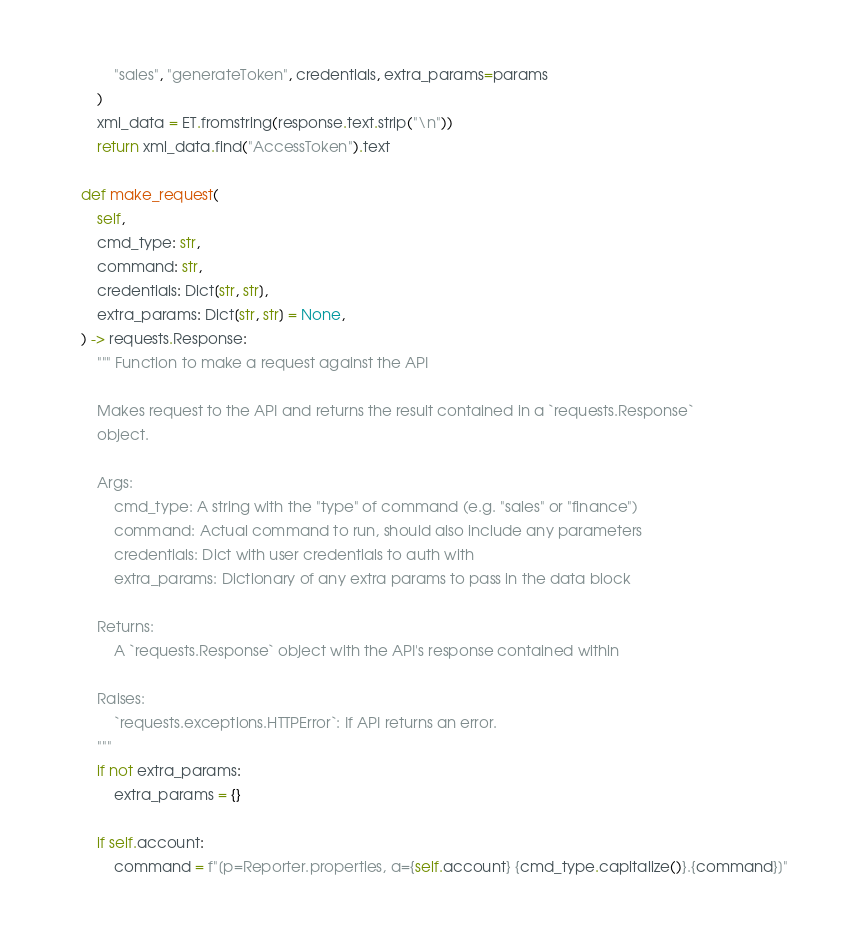Convert code to text. <code><loc_0><loc_0><loc_500><loc_500><_Python_>            "sales", "generateToken", credentials, extra_params=params
        )
        xml_data = ET.fromstring(response.text.strip("\n"))
        return xml_data.find("AccessToken").text

    def make_request(
        self,
        cmd_type: str,
        command: str,
        credentials: Dict[str, str],
        extra_params: Dict[str, str] = None,
    ) -> requests.Response:
        """ Function to make a request against the API

        Makes request to the API and returns the result contained in a `requests.Response`
        object.

        Args:
            cmd_type: A string with the "type" of command (e.g. "sales" or "finance")
            command: Actual command to run, should also include any parameters
            credentials: Dict with user credentials to auth with
            extra_params: Dictionary of any extra params to pass in the data block

        Returns:
            A `requests.Response` object with the API's response contained within

        Raises:
            `requests.exceptions.HTTPError`: If API returns an error.
        """
        if not extra_params:
            extra_params = {}

        if self.account:
            command = f"[p=Reporter.properties, a={self.account} {cmd_type.capitalize()}.{command}]"</code> 